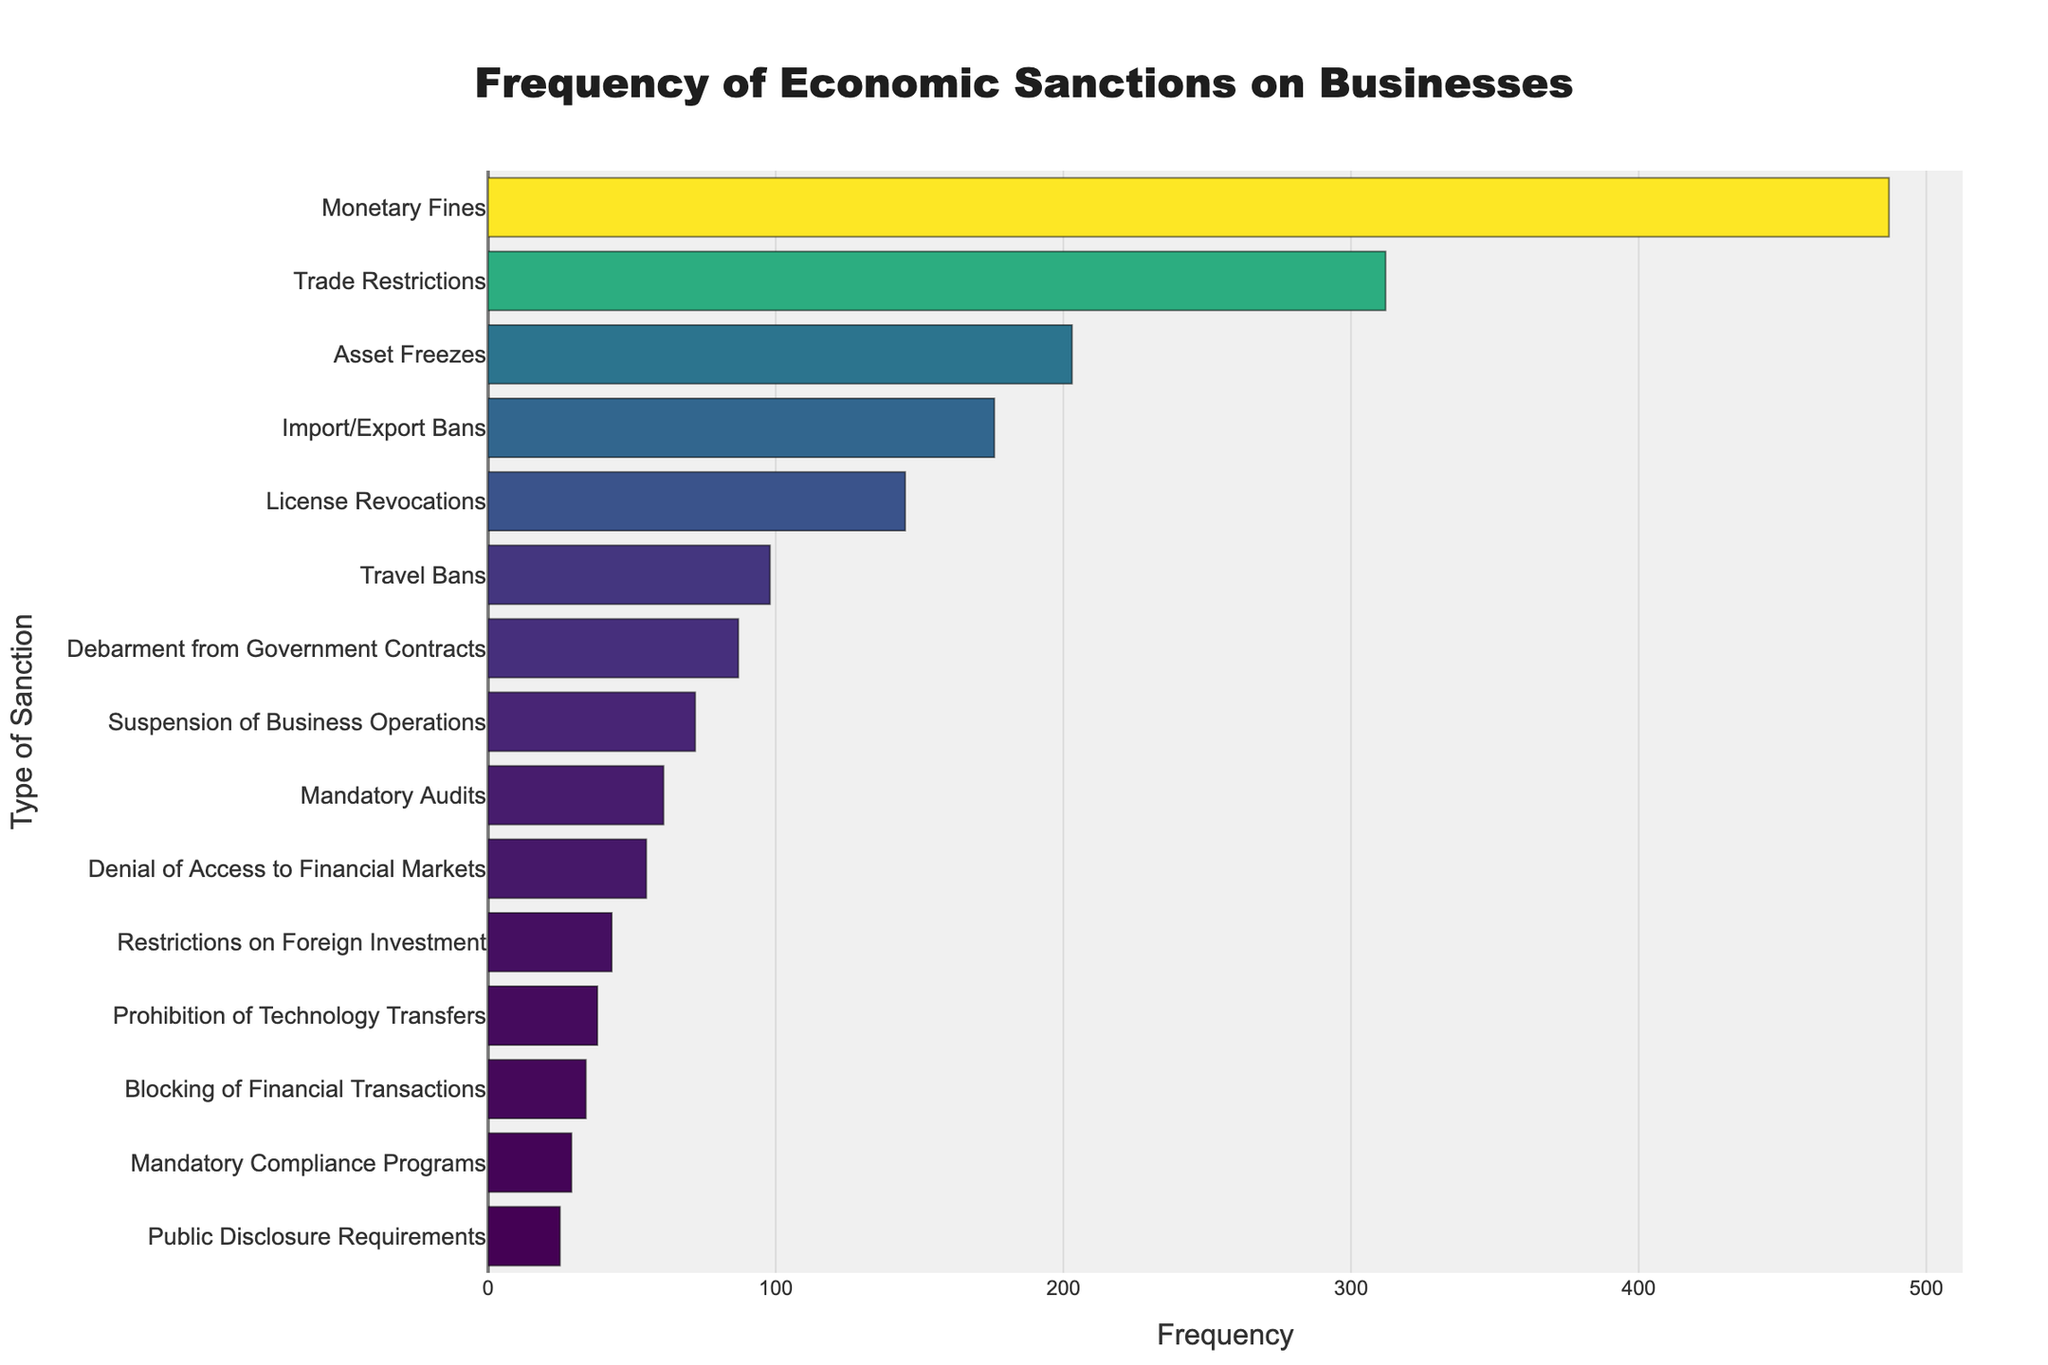What type of sanction is the most frequent? From the bar chart, the type of sanction with the longest bar represents the most frequent sanction. "Monetary Fines" has the longest bar.
Answer: Monetary Fines Which two sanctions have frequencies greater than 300? By examining the lengths of the bars, "Monetary Fines" and "Trade Restrictions" are the only two sanctions with frequencies above 300.
Answer: Monetary Fines and Trade Restrictions How much more frequent are Asset Freezes compared to Travel Bans? "Asset Freezes" has a frequency of 203, and "Travel Bans" has a frequency of 98. Subtract the frequency of Travel Bans from that of Asset Freezes: 203 - 98 = 105.
Answer: 105 What is the frequency difference between the least frequent and the most frequent sanctions? The least frequent sanction is "Public Disclosure Requirements" with a frequency of 25, and the most frequent is "Monetary Fines" with a frequency of 487. Subtract the least from the most: 487 - 25 = 462.
Answer: 462 Is the frequency of License Revocations greater than the combined frequency of Denial of Access to Financial Markets and Restrictions on Foreign Investment? "License Revocations" has a frequency of 145. "Denial of Access to Financial Markets" has a frequency of 55, and "Restrictions on Foreign Investment" has a frequency of 43. Adding the latter two: 55 + 43 = 98. Since 145 > 98, the answer is yes.
Answer: Yes Which sanction has a frequency closest to 60? By visually inspecting, "Mandatory Audits" has a frequency of 61, which is the closest to 60.
Answer: Mandatory Audits How many sanctions have a frequency of less than 50? By counting the bars with lengths corresponding to frequencies below 50, there are 4 sanctions: "Restrictions on Foreign Investment," "Prohibition of Technology Transfers," "Blocking of Financial Transactions," and "Mandatory Compliance Programs."
Answer: 4 What is the combined frequency of the three most frequent sanctions? The three most frequent sanctions are "Monetary Fines" (487), "Trade Restrictions" (312), and "Asset Freezes" (203). Sum them up: 487 + 312 + 203 = 1002.
Answer: 1002 Are there more sanctions with frequencies above 100 or below 100? First, count the number of sanctions with frequencies above 100: 5 (Monetary Fines, Trade Restrictions, Asset Freezes, Import/Export Bans, License Revocations). Then, count those below 100: 10 (Travel Bans, Debarment from Government Contracts, Suspension of Business Operations, Mandatory Audits, Denial of Access to Financial Markets, Restrictions on Foreign Investment, Prohibition of Technology Transfers, Blocking of Financial Transactions, Mandatory Compliance Programs, Public Disclosure Requirements). There are more sanctions with frequencies below 100.
Answer: Below 100 